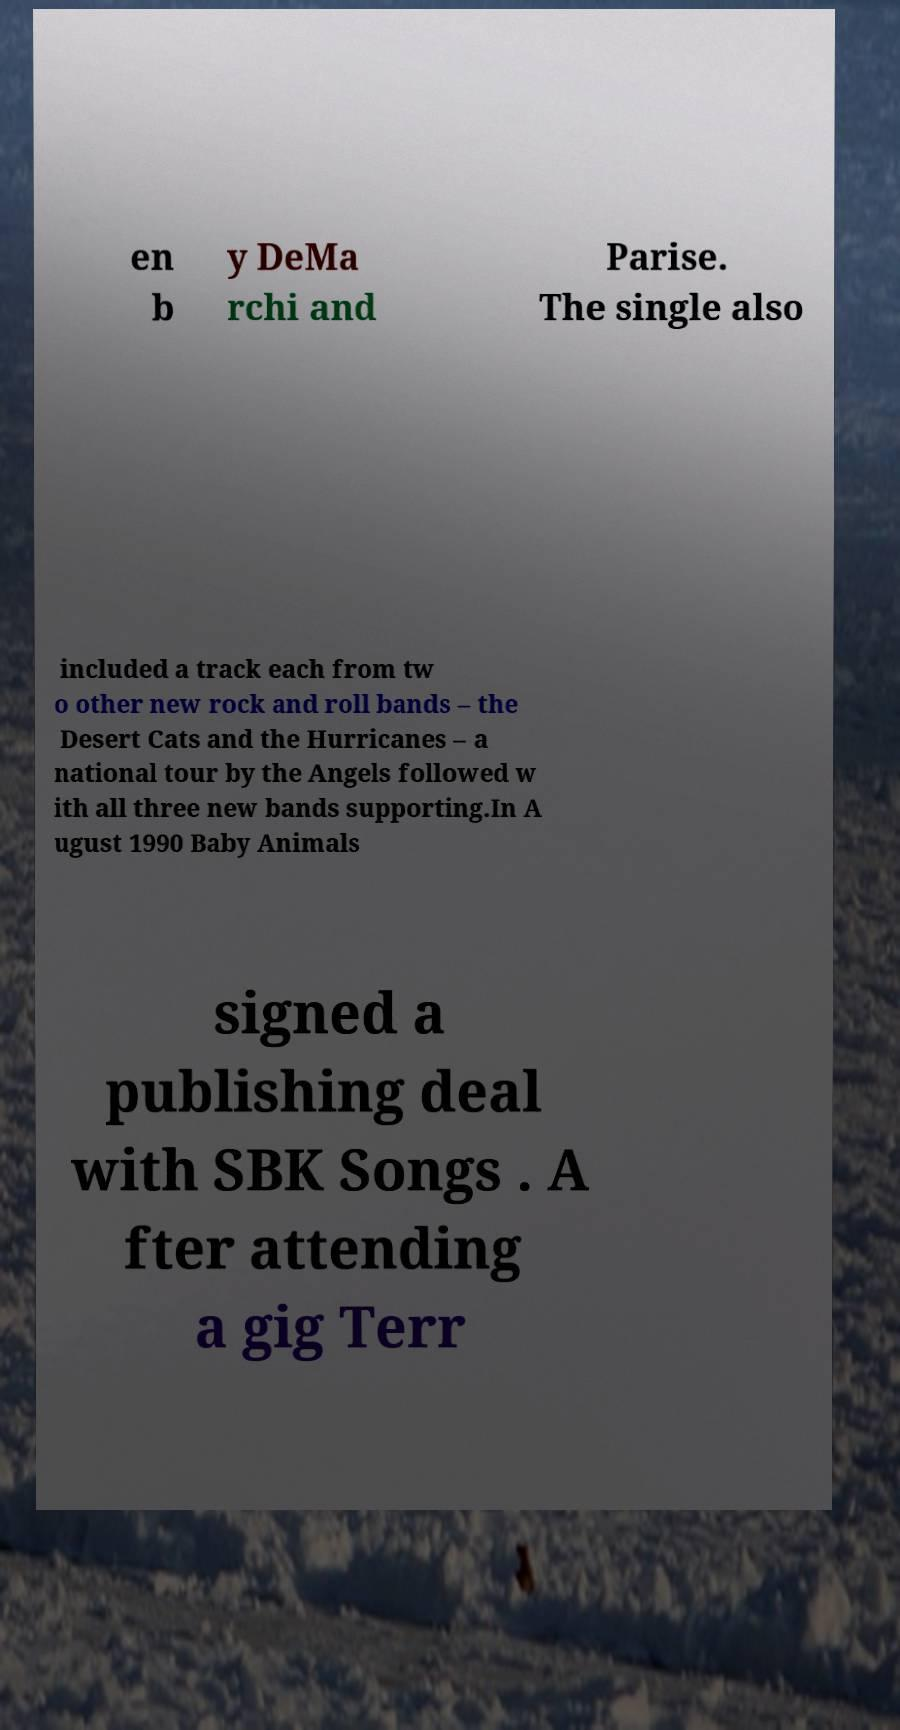I need the written content from this picture converted into text. Can you do that? en b y DeMa rchi and Parise. The single also included a track each from tw o other new rock and roll bands – the Desert Cats and the Hurricanes – a national tour by the Angels followed w ith all three new bands supporting.In A ugust 1990 Baby Animals signed a publishing deal with SBK Songs . A fter attending a gig Terr 